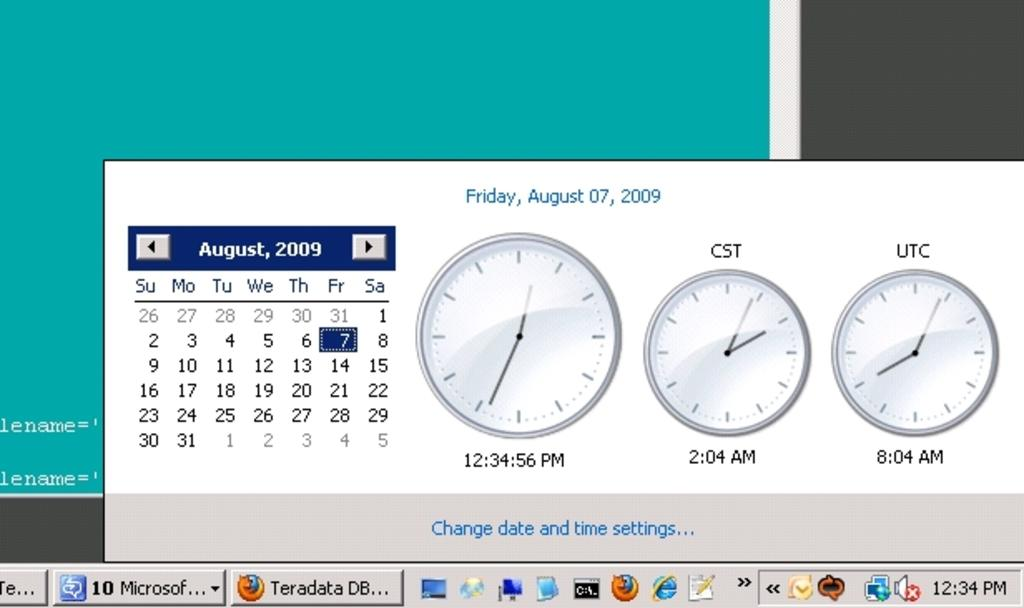<image>
Provide a brief description of the given image. The time settings window is open, showing the date of Friday, August 7, 2009. 